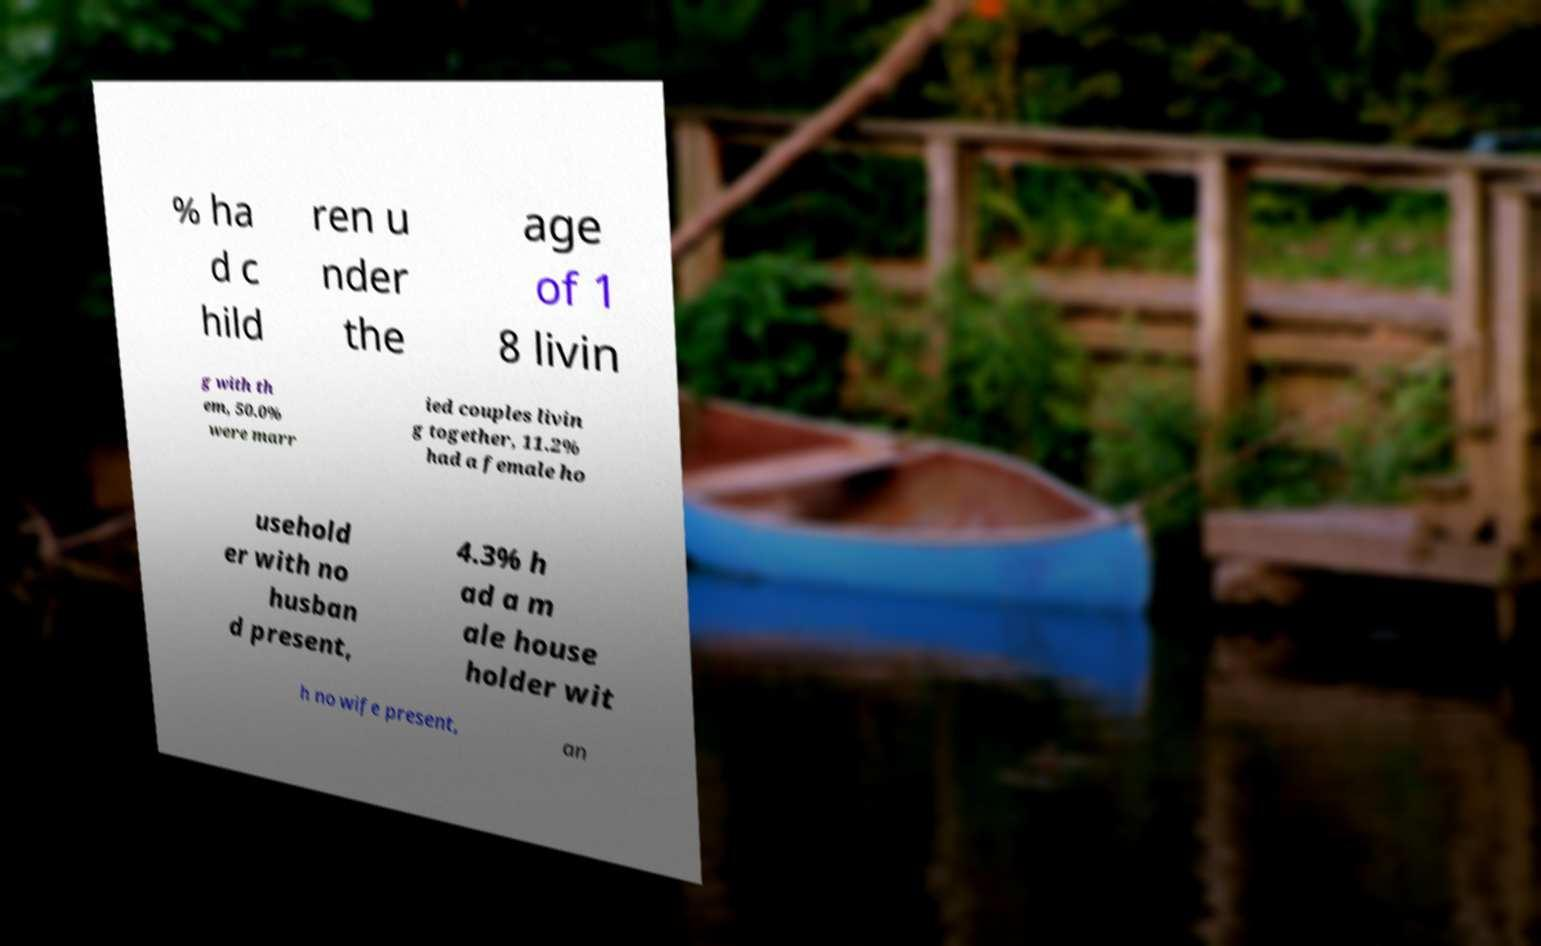Could you extract and type out the text from this image? % ha d c hild ren u nder the age of 1 8 livin g with th em, 50.0% were marr ied couples livin g together, 11.2% had a female ho usehold er with no husban d present, 4.3% h ad a m ale house holder wit h no wife present, an 